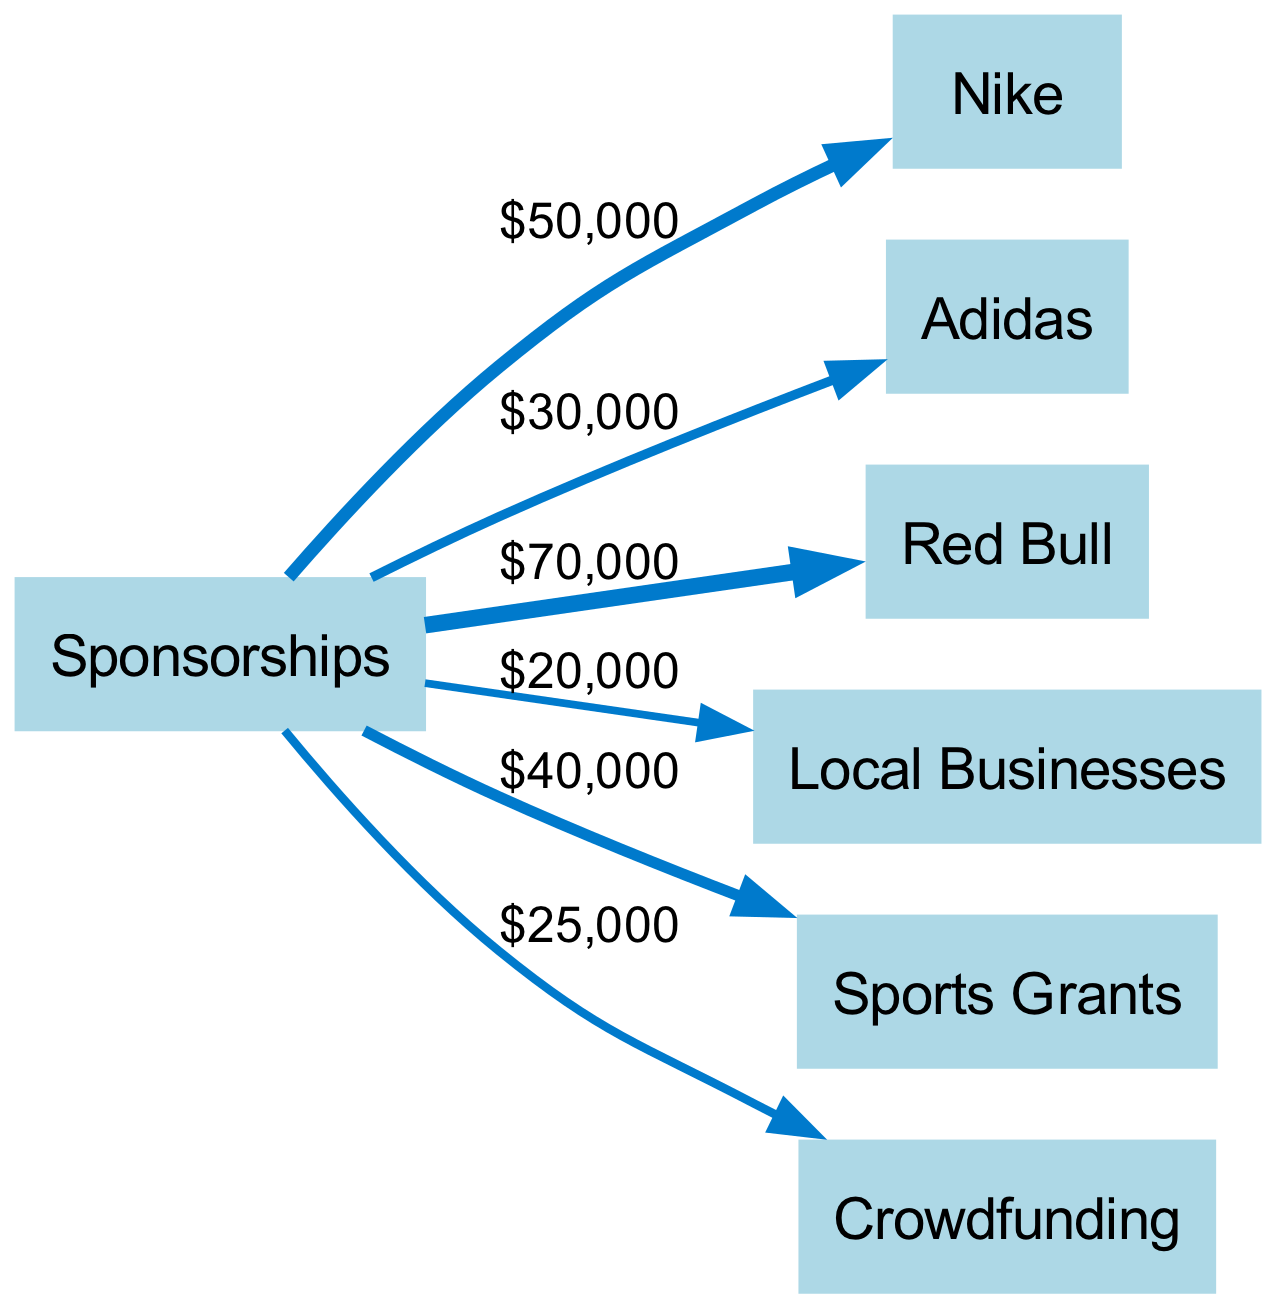What is the total amount contributed from sponsorships? To find the total contributed, we sum all the values associated with the sponsorships. The values are 50,000 from Nike, 30,000 from Adidas, 70,000 from Red Bull, 20,000 from Local Businesses, 40,000 from Sports Grants, and 25,000 from Crowdfunding. Adding these together gives us 50000 + 30000 + 70000 + 20000 + 40000 + 25000 = 190000.
Answer: 190000 Which sponsor contributed the most? By examining the values associated with each sponsor connected to the "Sponsorships" node, we can identify the highest number. Red Bull has a value of 70,000, which is larger than the contributions from other sponsors.
Answer: Red Bull What is the value of the contribution from Adidas? The diagram shows that the contribution from Adidas is clearly labeled as 30,000 next to the connecting line to the "Sponsorships" node. This direct observation allows us to find the value without additional calculations.
Answer: 30000 How many sponsors are there in total? To find the total number of sponsors, we count the distinct nodes connected to the "Sponsorships" node. These nodes are Nike, Adidas, Red Bull, Local Businesses, Sports Grants, and Crowdfunding, totaling 6 sponsors.
Answer: 6 Which sponsorship source is the least contributing? By checking the values connected to the "Sponsorships" node, we see that Local Businesses has the smallest value of 20,000. This makes it the least contributing source.
Answer: Local Businesses What is the combined contribution from Nike and Adidas? To find the combined contribution, we look at the individual contributions: Nike contributes 50,000 and Adidas contributes 30,000. Adding these two values gives 50000 + 30000 = 80000.
Answer: 80000 What percentage of the total does Crowdfunding contribute? The Crowdfunding contribution is 25,000. To find what percentage this is of the total 190,000, we calculate (25000 / 190000) * 100, which equals approximately 13.16%.
Answer: 13.16% What is the sum of contributions from Sports Grants and Local Businesses? We find the contributions for Sports Grants, which is 40,000, and Local Businesses, which is 20,000. Adding these together gives us 40000 + 20000 = 60000.
Answer: 60000 Which sponsorship source has a contribution value between 20,000 and 50,000? Among the contributions, Local Businesses at 20,000 and Nike at 50,000, we only find Sports Grants, which contributes 40,000, fitting the criteria of being between 20,000 and 50,000.
Answer: Sports Grants 